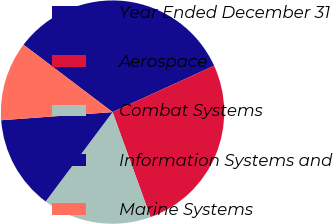Convert chart to OTSL. <chart><loc_0><loc_0><loc_500><loc_500><pie_chart><fcel>Year Ended December 31<fcel>Aerospace<fcel>Combat Systems<fcel>Information Systems and<fcel>Marine Systems<nl><fcel>32.87%<fcel>26.29%<fcel>15.75%<fcel>13.61%<fcel>11.47%<nl></chart> 